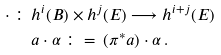<formula> <loc_0><loc_0><loc_500><loc_500>\cdot \, \colon \, & h ^ { i } ( B ) \times h ^ { j } ( E ) \longrightarrow h ^ { i + j } ( E ) \\ & a \cdot \alpha \, \colon = \, ( \pi ^ { * } a ) \cdot \alpha \, .</formula> 